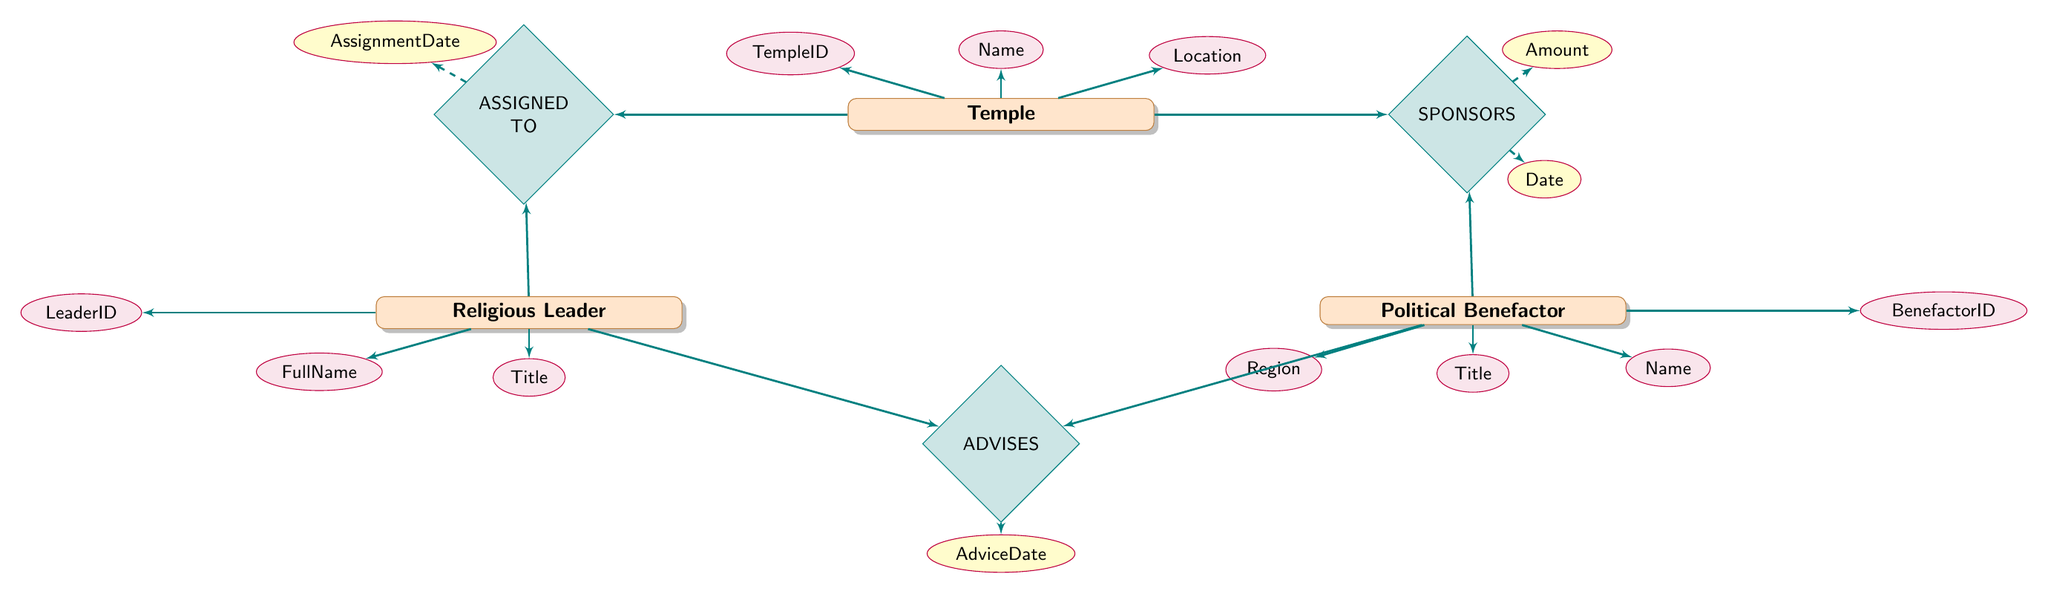What types of entities are represented in this diagram? The diagram contains three types of entities: Temple, Religious Leader, and Political Benefactor.
Answer: Temple, Religious Leader, Political Benefactor How many attributes does the Temple entity have? The Temple entity has three attributes: TempleID, Name, and Location.
Answer: 3 What is the name of the relationship between Political Benefactor and Temple? The relationship connecting Political Benefactor and Temple is labeled "SPONSORS."
Answer: SPONSORS What is the assignment date attribute for the relationship "ASSIGNED TO"? The assignment date is represented by the attribute "AssignmentDate" under the relationship "ASSIGNED TO."
Answer: AssignmentDate Which entity advises the Political Benefactor? The Religious Leader entity provides advice to the Political Benefactor.
Answer: Religious Leader How many relationships are there in total in this diagram? There are three relationships: SPONSORS, ASSIGNED TO, and ADVISES.
Answer: 3 What is the primary key for the Religious Leader entity? The primary key for the Religious Leader entity is "LeaderID."
Answer: LeaderID Which attribute associates a Political Benefactor with the amount contributed to a Temple? The contribution amount is captured by the attribute "Amount" associated with the "SPONSORS" relationship.
Answer: Amount Which entities are connected by the relationship "ADVISES"? The "ADVISES" relationship connects Religious Leader and Political Benefactor.
Answer: Religious Leader and Political Benefactor 